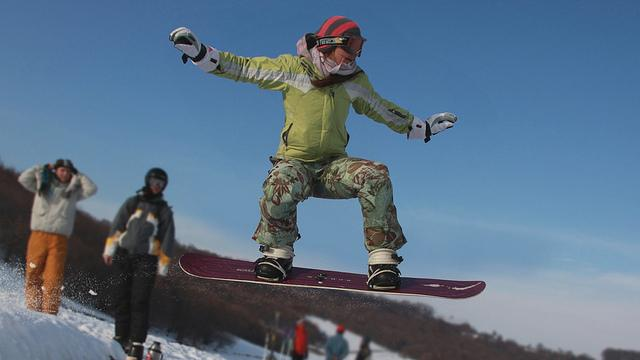Why are there straps on snowboards? Please explain your reasoning. support/response. They may also be b depending on the design, but they're primarily for a. 